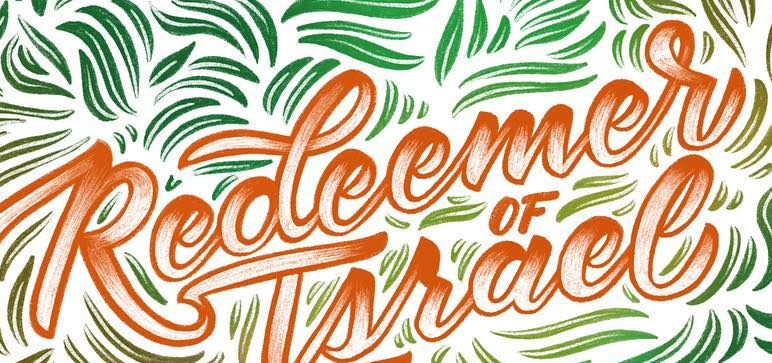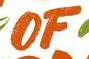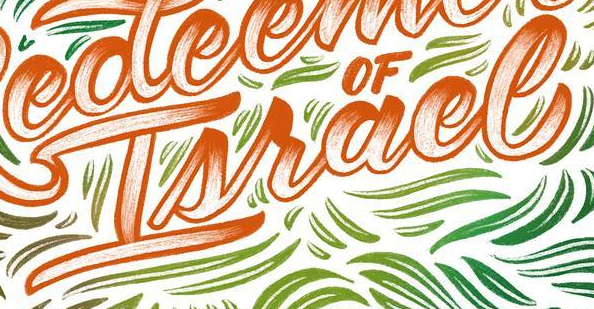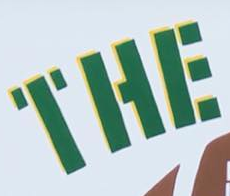What words can you see in these images in sequence, separated by a semicolon? Redeemer; OF; Israel; THE 